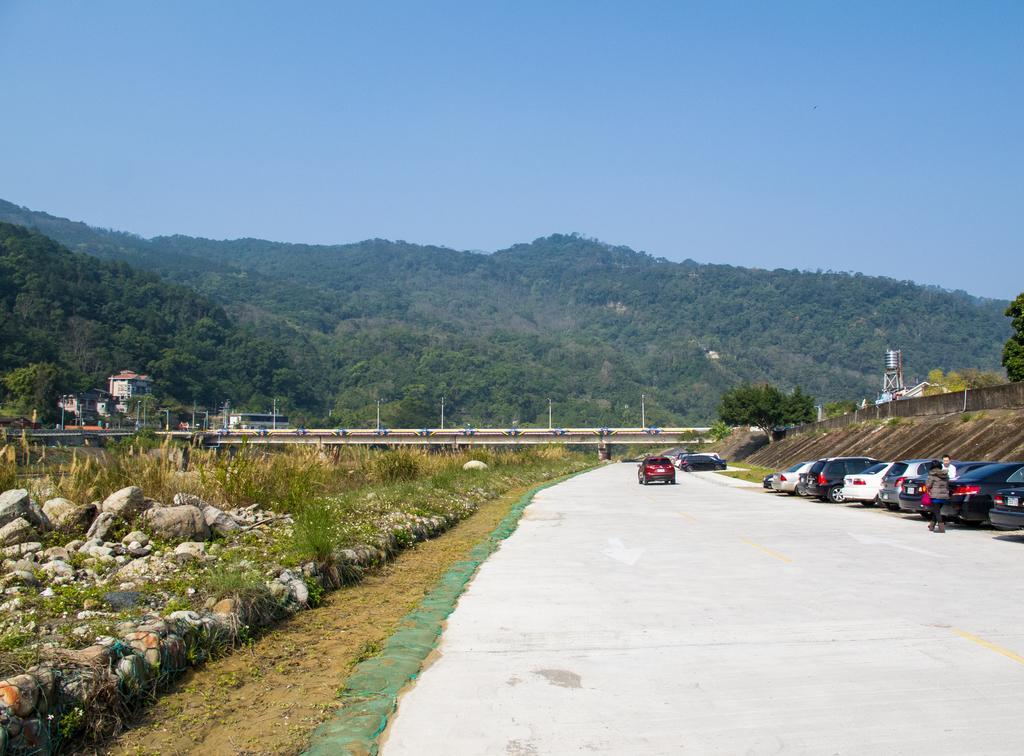Could you give a brief overview of what you see in this image? In this picture we can see some vehicles are parked beside the road, few vehicles are on the road , side we can see some people, rocks, trees, buildings, hills. 